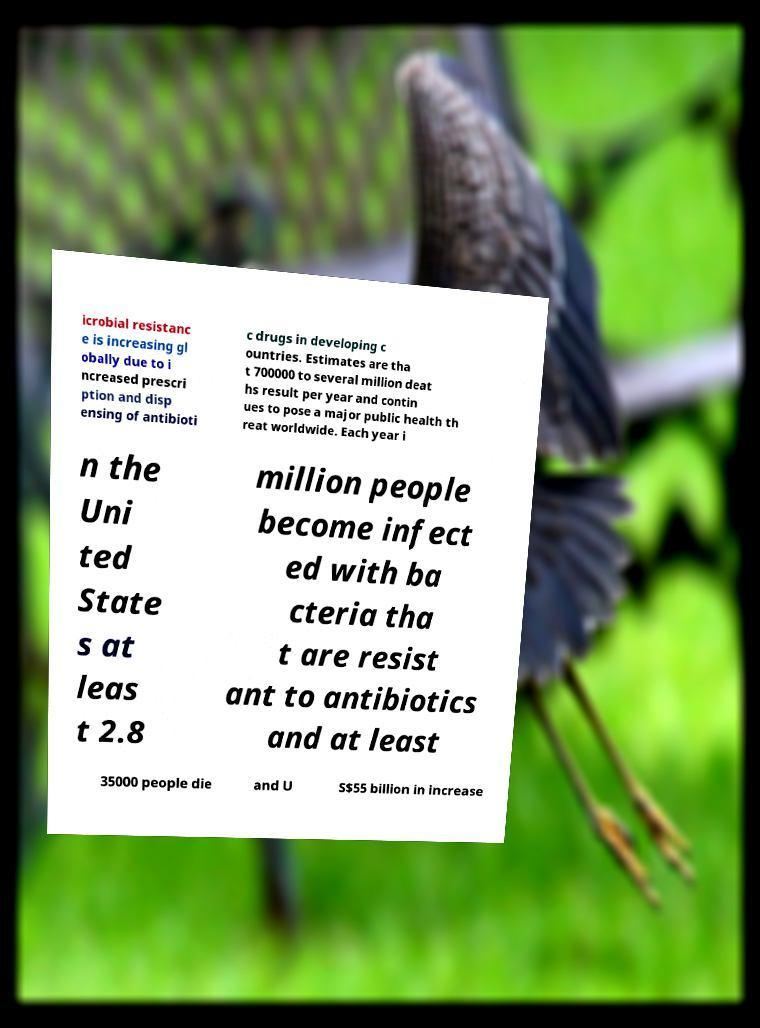Please read and relay the text visible in this image. What does it say? icrobial resistanc e is increasing gl obally due to i ncreased prescri ption and disp ensing of antibioti c drugs in developing c ountries. Estimates are tha t 700000 to several million deat hs result per year and contin ues to pose a major public health th reat worldwide. Each year i n the Uni ted State s at leas t 2.8 million people become infect ed with ba cteria tha t are resist ant to antibiotics and at least 35000 people die and U S$55 billion in increase 